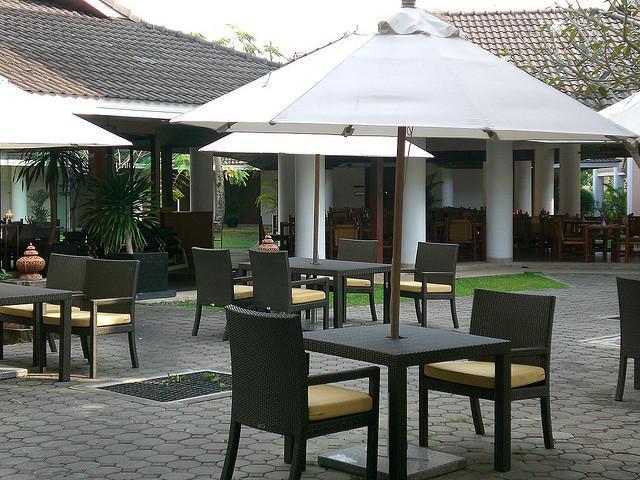How many chairs can you see?
Give a very brief answer. 9. How many chairs at the 3 tables?
Give a very brief answer. 8. How many chairs are in the picture?
Give a very brief answer. 9. How many umbrellas are there?
Give a very brief answer. 3. How many dining tables are in the photo?
Give a very brief answer. 3. 